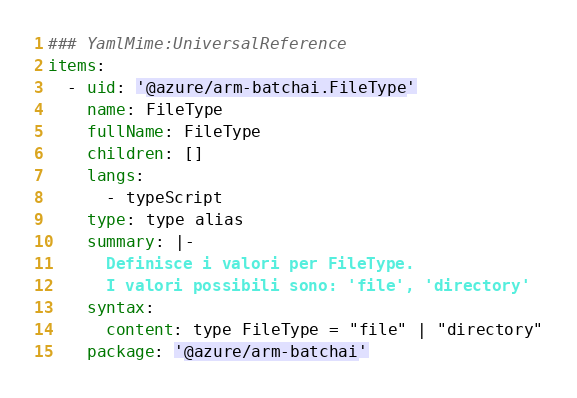<code> <loc_0><loc_0><loc_500><loc_500><_YAML_>### YamlMime:UniversalReference
items:
  - uid: '@azure/arm-batchai.FileType'
    name: FileType
    fullName: FileType
    children: []
    langs:
      - typeScript
    type: type alias
    summary: |-
      Definisce i valori per FileType.
      I valori possibili sono: 'file', 'directory'
    syntax:
      content: type FileType = "file" | "directory"
    package: '@azure/arm-batchai'</code> 